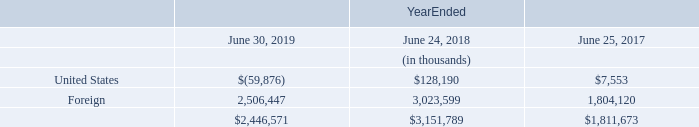Note 7: Income Taxes
On December 22, 2017, the “Tax Cuts & Jobs Act” was signed into law and was effective for the Company starting in the quarter ended December 24, 2017. U.S. tax reform reduced the U.S. federal statutory tax rate from 35% to 21%, assessed a one-time transition tax on earnings of certain foreign subsidiaries that were previously tax deferred, and created new taxes on certain foreign sourced earnings. The impact on income taxes due to a change in legislation is required under the authoritative guidance of Accounting Standards Codification (“ASC”) 740, Income Taxes, to be recognized in the period in which the law is enacted. In conjunction, the SEC issued Staff Accounting Bulletin (“SAB”) 118, which allowed for the recording of provisional amounts related to U.S. tax reform and subsequent adjustments related to U.S. tax reform during an up to one-year measurement period that is similar to the measurement period used when accounting for business combinations. The Company recorded what it believed to be reasonable estimates during the SAB 118 measurement period. During the December 2018 quarter, the Company finalized the accounting of the income tax effects of U.S. tax reform. Although the SAB 118 measurement period has ended, there may be some aspects of U.S. tax reform that remain subject to future regulations and/or notices which may further clarify certain provisions of U.S. tax reform. The Company may need to adjust its previously recorded amounts to reflect the recognition and measurement of its tax accounting positions in accordance with ASC 740; such adjustments could be material.
The computation of the one-time transition tax on accumulated unrepatriated foreign earnings was recorded on a provisional basis in the amount of $883.0 million in the fiscal year ended June 24, 2018, as permitted under SAB 118. The Company recorded a subsequent provisional adjustment of $36.6 million, as a result of incorporating new information into the estimate, in the Condensed Consolidated Financial Statements in the three months ended September 23, 2018. The Company finalized the computation of the transition tax liability during the December 2018 quarter. The final adjustment resulted in a tax benefit of $51.2 million, which was recorded in the Company’s Condensed Consolidated Financial Statements in the three months ended December 23, 2018. The final balance of total transition tax is $868.4 million. The one-time transition tax is based on the Company’s total post-1986 earnings and profits (“E&P”) that was previously deferred from U.S. income taxes. The Company had previously accrued deferred taxes on a portion of this E&P. The Company has completed the calculation of total post-1986 E&P and related income tax pools for its foreign subsidiaries. The Company elected to pay the one-time transition tax over a period of eight years.
Beginning in fiscal year 2019, the Company is subject to the impact of the GILTI provision of U.S. tax reform. The GILTI provision imposes taxes on foreign earnings in excess of a deemed return on tangible assets. The Company has calculated the impact of the GILTI provision on current year earnings and has included the impact in the effective tax rate. The Company made an accounting policy election in the September 2018 quarter to record deferred taxes in relation to the GILTI provision, and recorded a provisional tax benefit of $48.0 million in the Condensed Consolidated Financial Statements in the three months ended September 23, 2018, under SAB 118. The Company finalized the computation of the accounting policy election during the December 2018 quarter. The final adjustment resulted in a tax expense of $0.4 million, which was recorded in the Company’s Condensed Consolidated Financial Statements in the three months ended December 23, 2018. The final tax benefit of the election is $47.6 million.
The components of income (loss) before income taxes were as follows:
What was the one-time transition tax on accumulated unrepatriated foreign earnings in the fiscal year ended June 24, 2018? $883.0 million. What was the period of time the Company chose to pay the one-time transition tax? Over a period of eight years. What was the income before income taxes from United States in 2018?
Answer scale should be: thousand. $128,190. What is the percentage change in the income before income taxes from United States from 2017 to 2018?
Answer scale should be: percent. (128,190-7,553)/7,553
Answer: 1597.21. What is the percentage change in the income before income taxes from Foreign countries from 2018 to 2019?
Answer scale should be: percent. (2,506,447-3,023,599)/3,023,599
Answer: -17.1. In which year is the income before income taxes from Foreign countries the highest? Find the year with the highest income before income taxes from Foreign countries
Answer: 2018. 